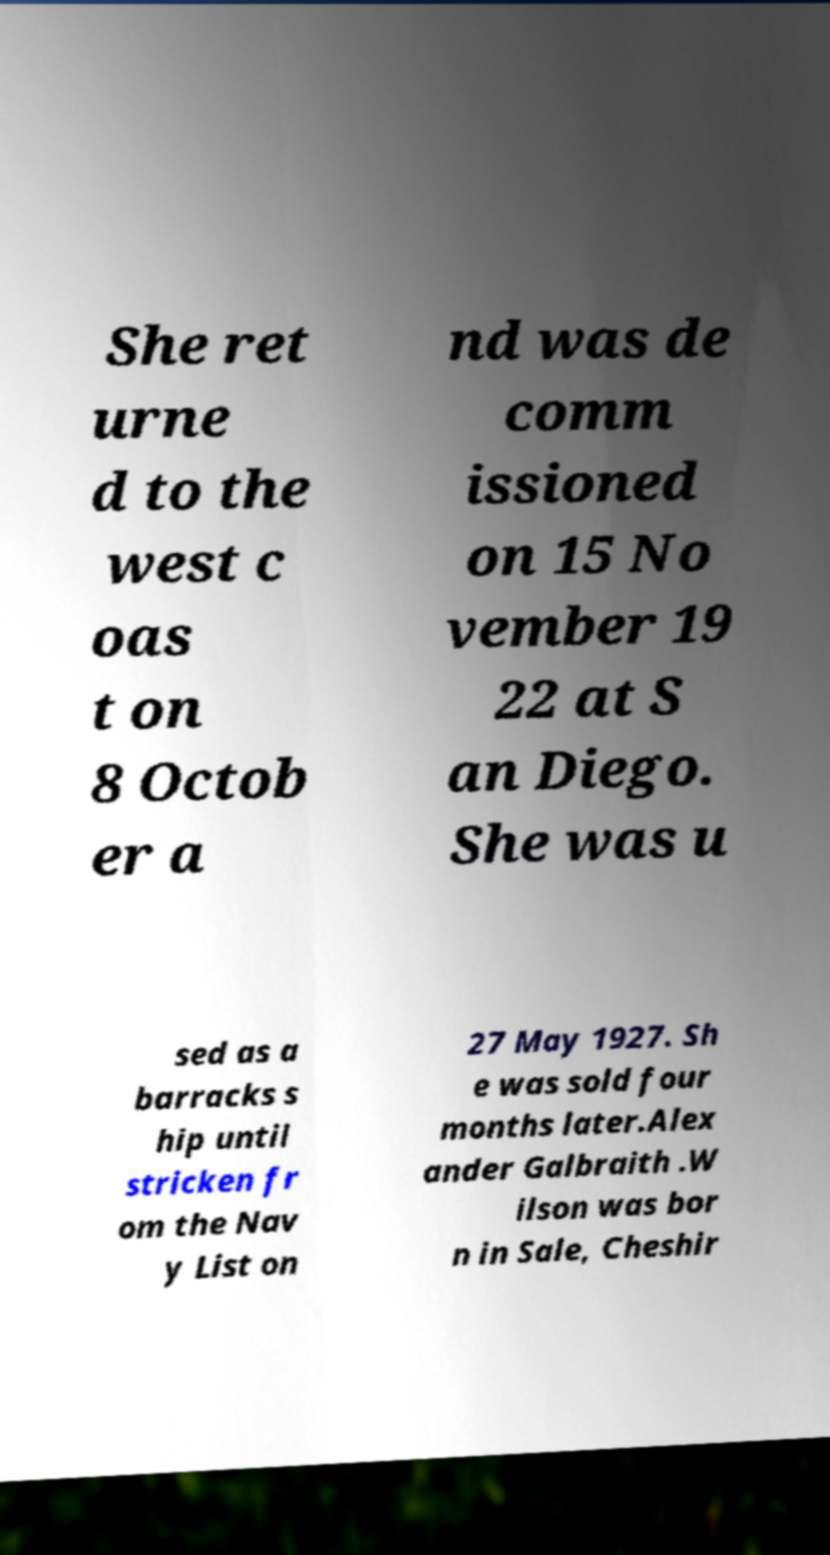Could you assist in decoding the text presented in this image and type it out clearly? She ret urne d to the west c oas t on 8 Octob er a nd was de comm issioned on 15 No vember 19 22 at S an Diego. She was u sed as a barracks s hip until stricken fr om the Nav y List on 27 May 1927. Sh e was sold four months later.Alex ander Galbraith .W ilson was bor n in Sale, Cheshir 